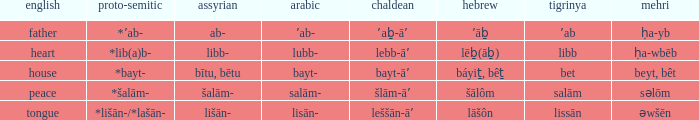If the geez is libb, what is the akkadian? Libb-. 